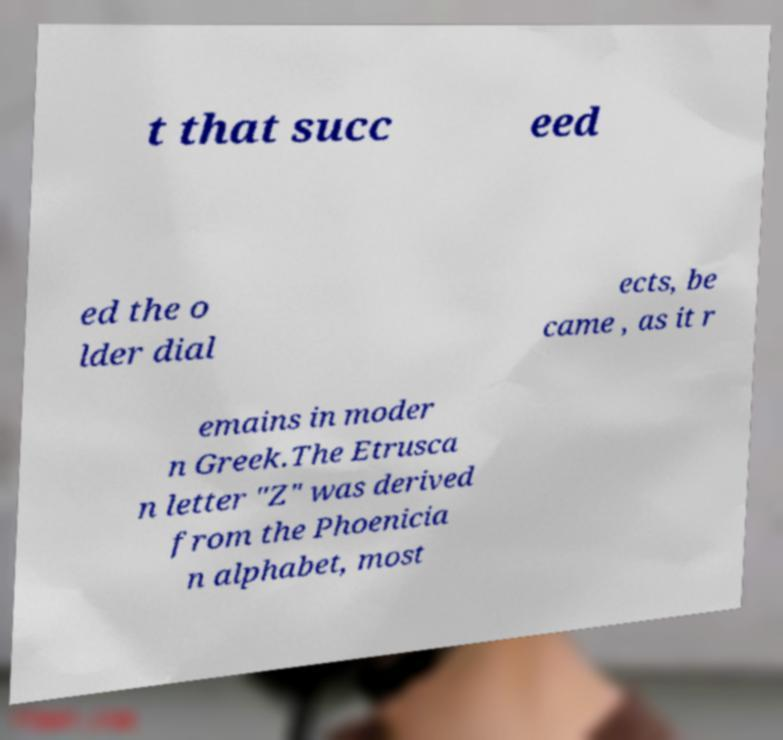Can you accurately transcribe the text from the provided image for me? t that succ eed ed the o lder dial ects, be came , as it r emains in moder n Greek.The Etrusca n letter "Z" was derived from the Phoenicia n alphabet, most 